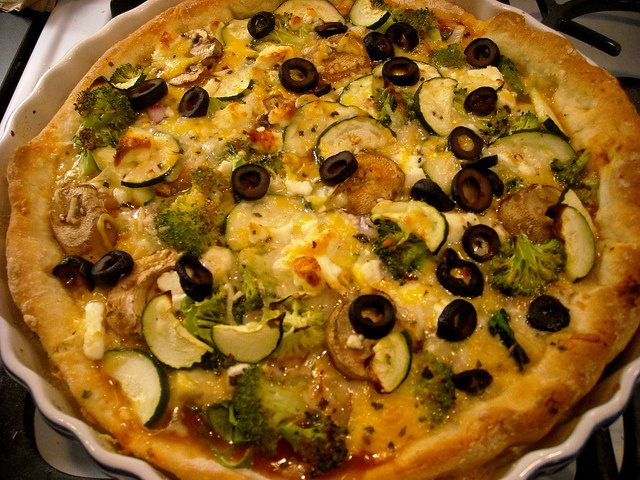Describe the objects in this image and their specific colors. I can see bowl in olive, black, orange, and maroon tones and pizza in olive, black, orange, and maroon tones in this image. 